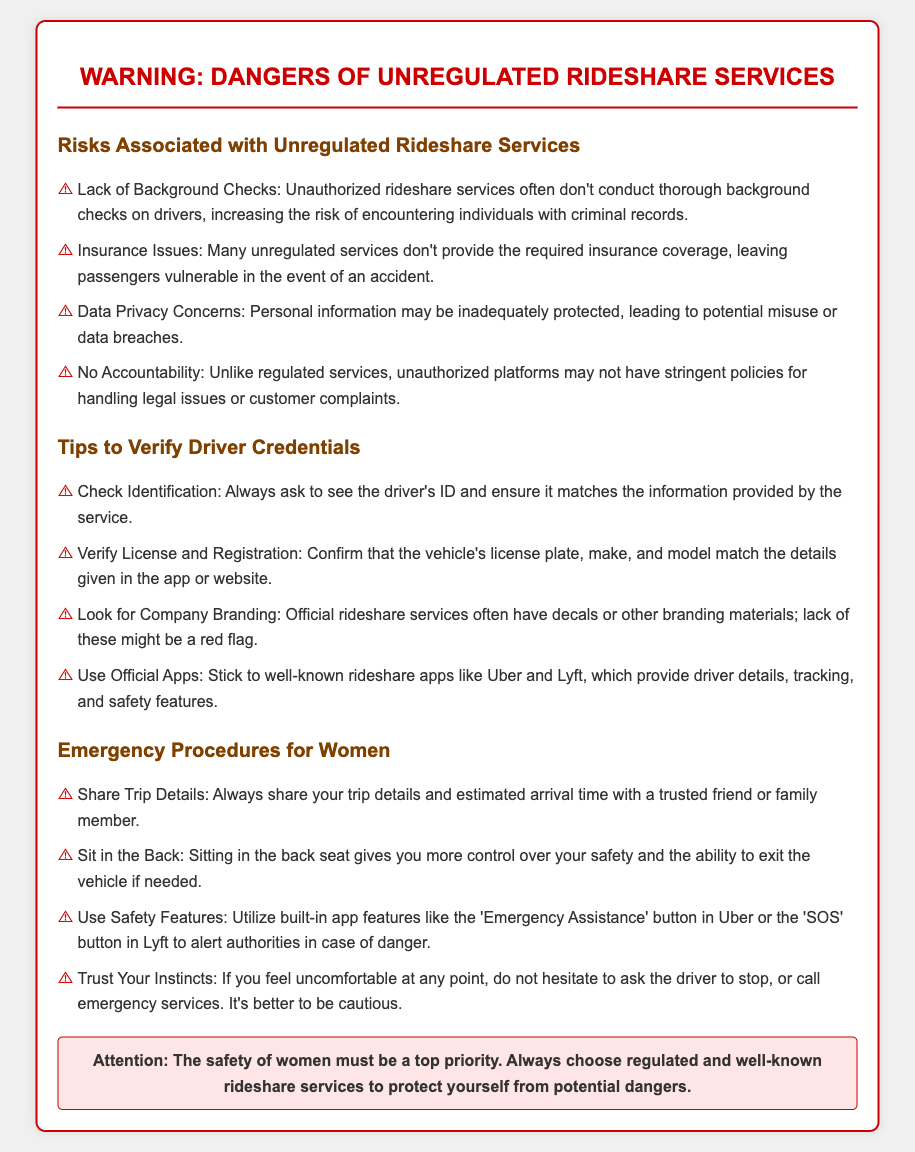What are the main risks of unregulated rideshare services? The main risks associated with unregulated rideshare services include lack of background checks, insurance issues, data privacy concerns, and no accountability.
Answer: Lack of Background Checks, Insurance Issues, Data Privacy Concerns, No Accountability What is one way to verify a driver's credentials? One way to verify a driver's credentials is to check their identification and ensure it matches the information provided by the service.
Answer: Check Identification What should women do with their trip details? Women should always share their trip details and estimated arrival time with a trusted friend or family member.
Answer: Share Trip Details Which rideshare apps are recommended in the document? The document recommends using well-known rideshare apps like Uber and Lyft.
Answer: Uber and Lyft What color is the header text of the document? The header text color of the document is red, specifically indicated with the color code cc0000.
Answer: Red What action should a woman take if she feels uncomfortable during a ride? If a woman feels uncomfortable, she should not hesitate to ask the driver to stop or call emergency services.
Answer: Ask the driver to stop or call emergency services Which feature can be used to alert authorities in case of danger? The feature to alert authorities in case of danger is the 'Emergency Assistance' button in Uber or the 'SOS' button in Lyft.
Answer: Emergency Assistance button in Uber or SOS button in Lyft What is the overall message of the document? The overall message of the document emphasizes that the safety of women must be a top priority in choosing rideshare services.
Answer: The safety of women must be a top priority 